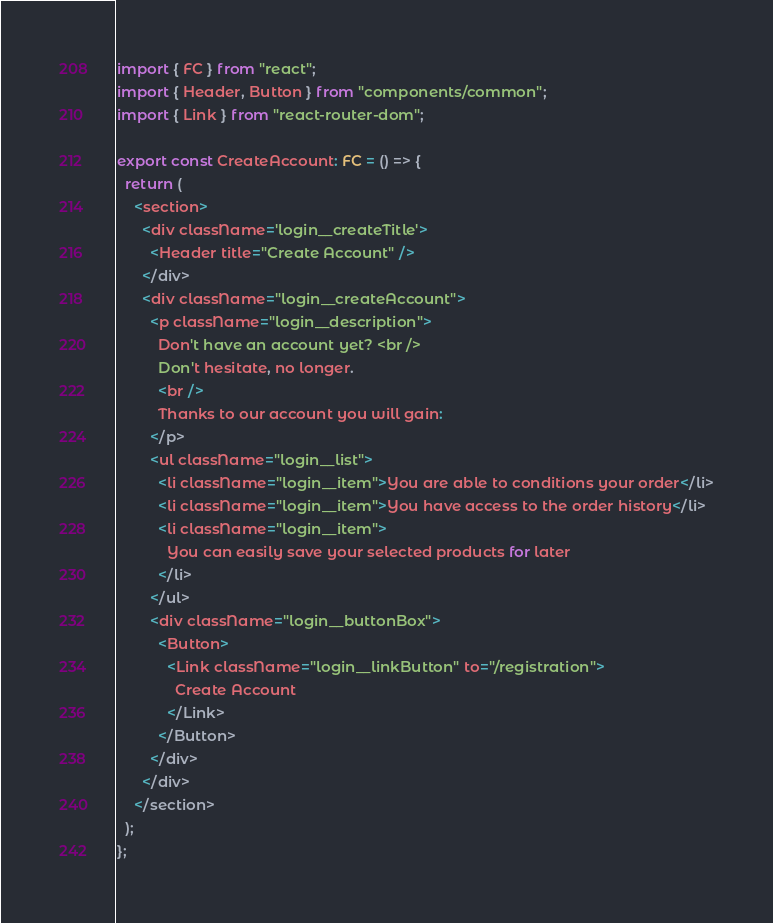Convert code to text. <code><loc_0><loc_0><loc_500><loc_500><_TypeScript_>import { FC } from "react";
import { Header, Button } from "components/common";
import { Link } from "react-router-dom";

export const CreateAccount: FC = () => {
  return (
    <section>
      <div className='login__createTitle'>
        <Header title="Create Account" />
      </div>
      <div className="login__createAccount">
        <p className="login__description">
          Don't have an account yet? <br />
          Don't hesitate, no longer.
          <br />
          Thanks to our account you will gain:
        </p>
        <ul className="login__list">
          <li className="login__item">You are able to conditions your order</li>
          <li className="login__item">You have access to the order history</li>
          <li className="login__item">
            You can easily save your selected products for later
          </li>
        </ul>
        <div className="login__buttonBox">
          <Button>
            <Link className="login__linkButton" to="/registration">
              Create Account
            </Link>
          </Button>
        </div>
      </div>
    </section>
  );
};
</code> 